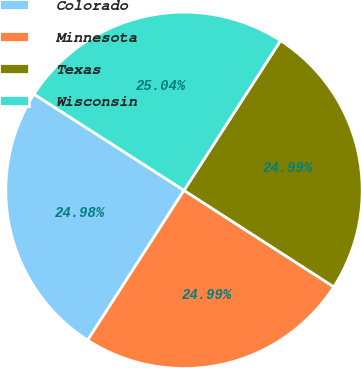<chart> <loc_0><loc_0><loc_500><loc_500><pie_chart><fcel>Colorado<fcel>Minnesota<fcel>Texas<fcel>Wisconsin<nl><fcel>24.98%<fcel>24.99%<fcel>24.99%<fcel>25.04%<nl></chart> 